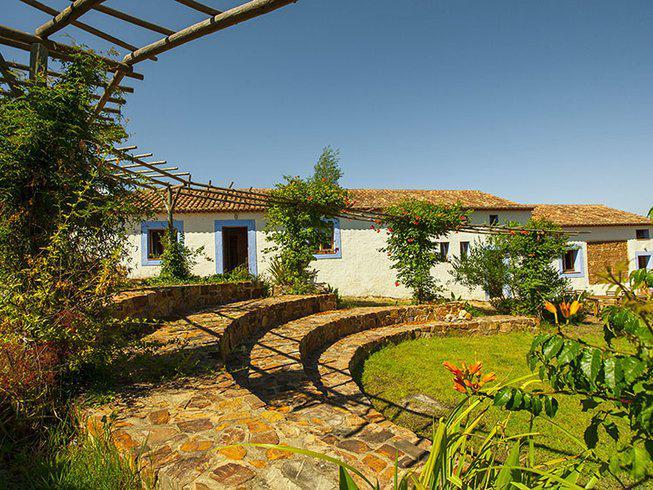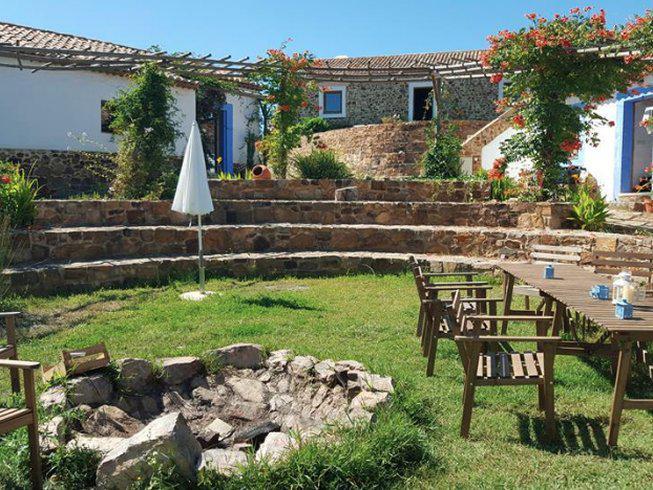The first image is the image on the left, the second image is the image on the right. For the images shown, is this caption "The right image includes rustic curving walls made of stones of varying shapes." true? Answer yes or no. Yes. The first image is the image on the left, the second image is the image on the right. For the images shown, is this caption "There are chairs outside." true? Answer yes or no. Yes. 